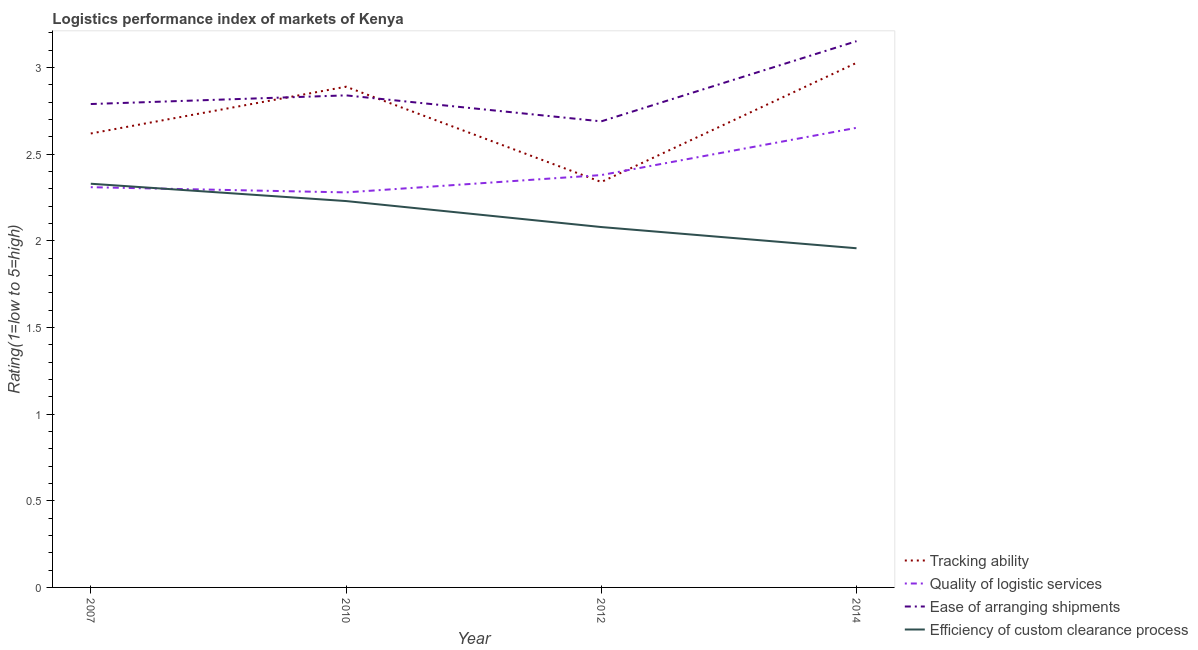How many different coloured lines are there?
Provide a short and direct response. 4. What is the lpi rating of efficiency of custom clearance process in 2014?
Your response must be concise. 1.96. Across all years, what is the maximum lpi rating of ease of arranging shipments?
Your answer should be very brief. 3.15. Across all years, what is the minimum lpi rating of quality of logistic services?
Make the answer very short. 2.28. What is the total lpi rating of ease of arranging shipments in the graph?
Provide a succinct answer. 11.47. What is the difference between the lpi rating of efficiency of custom clearance process in 2007 and that in 2010?
Offer a terse response. 0.1. What is the difference between the lpi rating of quality of logistic services in 2012 and the lpi rating of tracking ability in 2010?
Ensure brevity in your answer.  -0.51. What is the average lpi rating of quality of logistic services per year?
Offer a terse response. 2.41. In the year 2010, what is the difference between the lpi rating of quality of logistic services and lpi rating of tracking ability?
Your answer should be very brief. -0.61. What is the ratio of the lpi rating of efficiency of custom clearance process in 2012 to that in 2014?
Your answer should be compact. 1.06. Is the lpi rating of ease of arranging shipments in 2007 less than that in 2012?
Keep it short and to the point. No. Is the difference between the lpi rating of ease of arranging shipments in 2010 and 2012 greater than the difference between the lpi rating of quality of logistic services in 2010 and 2012?
Make the answer very short. Yes. What is the difference between the highest and the second highest lpi rating of efficiency of custom clearance process?
Make the answer very short. 0.1. What is the difference between the highest and the lowest lpi rating of ease of arranging shipments?
Offer a terse response. 0.46. In how many years, is the lpi rating of efficiency of custom clearance process greater than the average lpi rating of efficiency of custom clearance process taken over all years?
Keep it short and to the point. 2. Is the sum of the lpi rating of ease of arranging shipments in 2012 and 2014 greater than the maximum lpi rating of efficiency of custom clearance process across all years?
Keep it short and to the point. Yes. Is it the case that in every year, the sum of the lpi rating of ease of arranging shipments and lpi rating of quality of logistic services is greater than the sum of lpi rating of efficiency of custom clearance process and lpi rating of tracking ability?
Your answer should be very brief. Yes. Does the lpi rating of efficiency of custom clearance process monotonically increase over the years?
Provide a succinct answer. No. Is the lpi rating of efficiency of custom clearance process strictly greater than the lpi rating of ease of arranging shipments over the years?
Keep it short and to the point. No. How many years are there in the graph?
Give a very brief answer. 4. What is the difference between two consecutive major ticks on the Y-axis?
Keep it short and to the point. 0.5. Does the graph contain grids?
Your response must be concise. No. How many legend labels are there?
Offer a terse response. 4. What is the title of the graph?
Offer a very short reply. Logistics performance index of markets of Kenya. What is the label or title of the Y-axis?
Your response must be concise. Rating(1=low to 5=high). What is the Rating(1=low to 5=high) in Tracking ability in 2007?
Your answer should be compact. 2.62. What is the Rating(1=low to 5=high) in Quality of logistic services in 2007?
Make the answer very short. 2.31. What is the Rating(1=low to 5=high) of Ease of arranging shipments in 2007?
Your response must be concise. 2.79. What is the Rating(1=low to 5=high) in Efficiency of custom clearance process in 2007?
Provide a short and direct response. 2.33. What is the Rating(1=low to 5=high) of Tracking ability in 2010?
Keep it short and to the point. 2.89. What is the Rating(1=low to 5=high) in Quality of logistic services in 2010?
Make the answer very short. 2.28. What is the Rating(1=low to 5=high) of Ease of arranging shipments in 2010?
Your answer should be very brief. 2.84. What is the Rating(1=low to 5=high) in Efficiency of custom clearance process in 2010?
Your response must be concise. 2.23. What is the Rating(1=low to 5=high) of Tracking ability in 2012?
Keep it short and to the point. 2.34. What is the Rating(1=low to 5=high) in Quality of logistic services in 2012?
Provide a short and direct response. 2.38. What is the Rating(1=low to 5=high) of Ease of arranging shipments in 2012?
Offer a terse response. 2.69. What is the Rating(1=low to 5=high) in Efficiency of custom clearance process in 2012?
Ensure brevity in your answer.  2.08. What is the Rating(1=low to 5=high) of Tracking ability in 2014?
Your response must be concise. 3.03. What is the Rating(1=low to 5=high) of Quality of logistic services in 2014?
Your response must be concise. 2.65. What is the Rating(1=low to 5=high) of Ease of arranging shipments in 2014?
Give a very brief answer. 3.15. What is the Rating(1=low to 5=high) of Efficiency of custom clearance process in 2014?
Give a very brief answer. 1.96. Across all years, what is the maximum Rating(1=low to 5=high) of Tracking ability?
Offer a terse response. 3.03. Across all years, what is the maximum Rating(1=low to 5=high) in Quality of logistic services?
Make the answer very short. 2.65. Across all years, what is the maximum Rating(1=low to 5=high) in Ease of arranging shipments?
Keep it short and to the point. 3.15. Across all years, what is the maximum Rating(1=low to 5=high) in Efficiency of custom clearance process?
Your answer should be compact. 2.33. Across all years, what is the minimum Rating(1=low to 5=high) of Tracking ability?
Your answer should be compact. 2.34. Across all years, what is the minimum Rating(1=low to 5=high) of Quality of logistic services?
Provide a short and direct response. 2.28. Across all years, what is the minimum Rating(1=low to 5=high) of Ease of arranging shipments?
Your response must be concise. 2.69. Across all years, what is the minimum Rating(1=low to 5=high) of Efficiency of custom clearance process?
Make the answer very short. 1.96. What is the total Rating(1=low to 5=high) in Tracking ability in the graph?
Offer a terse response. 10.88. What is the total Rating(1=low to 5=high) in Quality of logistic services in the graph?
Keep it short and to the point. 9.62. What is the total Rating(1=low to 5=high) in Ease of arranging shipments in the graph?
Your answer should be very brief. 11.47. What is the total Rating(1=low to 5=high) in Efficiency of custom clearance process in the graph?
Ensure brevity in your answer.  8.6. What is the difference between the Rating(1=low to 5=high) of Tracking ability in 2007 and that in 2010?
Provide a short and direct response. -0.27. What is the difference between the Rating(1=low to 5=high) in Quality of logistic services in 2007 and that in 2010?
Offer a terse response. 0.03. What is the difference between the Rating(1=low to 5=high) in Efficiency of custom clearance process in 2007 and that in 2010?
Make the answer very short. 0.1. What is the difference between the Rating(1=low to 5=high) in Tracking ability in 2007 and that in 2012?
Provide a succinct answer. 0.28. What is the difference between the Rating(1=low to 5=high) of Quality of logistic services in 2007 and that in 2012?
Your response must be concise. -0.07. What is the difference between the Rating(1=low to 5=high) in Tracking ability in 2007 and that in 2014?
Provide a succinct answer. -0.41. What is the difference between the Rating(1=low to 5=high) in Quality of logistic services in 2007 and that in 2014?
Provide a succinct answer. -0.34. What is the difference between the Rating(1=low to 5=high) of Ease of arranging shipments in 2007 and that in 2014?
Keep it short and to the point. -0.36. What is the difference between the Rating(1=low to 5=high) in Efficiency of custom clearance process in 2007 and that in 2014?
Provide a short and direct response. 0.37. What is the difference between the Rating(1=low to 5=high) of Tracking ability in 2010 and that in 2012?
Provide a succinct answer. 0.55. What is the difference between the Rating(1=low to 5=high) in Quality of logistic services in 2010 and that in 2012?
Your response must be concise. -0.1. What is the difference between the Rating(1=low to 5=high) of Tracking ability in 2010 and that in 2014?
Your answer should be compact. -0.14. What is the difference between the Rating(1=low to 5=high) in Quality of logistic services in 2010 and that in 2014?
Provide a succinct answer. -0.37. What is the difference between the Rating(1=low to 5=high) of Ease of arranging shipments in 2010 and that in 2014?
Offer a very short reply. -0.31. What is the difference between the Rating(1=low to 5=high) of Efficiency of custom clearance process in 2010 and that in 2014?
Your answer should be very brief. 0.27. What is the difference between the Rating(1=low to 5=high) in Tracking ability in 2012 and that in 2014?
Keep it short and to the point. -0.69. What is the difference between the Rating(1=low to 5=high) in Quality of logistic services in 2012 and that in 2014?
Your answer should be compact. -0.27. What is the difference between the Rating(1=low to 5=high) of Ease of arranging shipments in 2012 and that in 2014?
Ensure brevity in your answer.  -0.46. What is the difference between the Rating(1=low to 5=high) of Efficiency of custom clearance process in 2012 and that in 2014?
Your response must be concise. 0.12. What is the difference between the Rating(1=low to 5=high) of Tracking ability in 2007 and the Rating(1=low to 5=high) of Quality of logistic services in 2010?
Give a very brief answer. 0.34. What is the difference between the Rating(1=low to 5=high) of Tracking ability in 2007 and the Rating(1=low to 5=high) of Ease of arranging shipments in 2010?
Make the answer very short. -0.22. What is the difference between the Rating(1=low to 5=high) of Tracking ability in 2007 and the Rating(1=low to 5=high) of Efficiency of custom clearance process in 2010?
Keep it short and to the point. 0.39. What is the difference between the Rating(1=low to 5=high) in Quality of logistic services in 2007 and the Rating(1=low to 5=high) in Ease of arranging shipments in 2010?
Give a very brief answer. -0.53. What is the difference between the Rating(1=low to 5=high) in Quality of logistic services in 2007 and the Rating(1=low to 5=high) in Efficiency of custom clearance process in 2010?
Provide a succinct answer. 0.08. What is the difference between the Rating(1=low to 5=high) in Ease of arranging shipments in 2007 and the Rating(1=low to 5=high) in Efficiency of custom clearance process in 2010?
Your answer should be very brief. 0.56. What is the difference between the Rating(1=low to 5=high) of Tracking ability in 2007 and the Rating(1=low to 5=high) of Quality of logistic services in 2012?
Provide a succinct answer. 0.24. What is the difference between the Rating(1=low to 5=high) in Tracking ability in 2007 and the Rating(1=low to 5=high) in Ease of arranging shipments in 2012?
Ensure brevity in your answer.  -0.07. What is the difference between the Rating(1=low to 5=high) of Tracking ability in 2007 and the Rating(1=low to 5=high) of Efficiency of custom clearance process in 2012?
Offer a terse response. 0.54. What is the difference between the Rating(1=low to 5=high) of Quality of logistic services in 2007 and the Rating(1=low to 5=high) of Ease of arranging shipments in 2012?
Keep it short and to the point. -0.38. What is the difference between the Rating(1=low to 5=high) of Quality of logistic services in 2007 and the Rating(1=low to 5=high) of Efficiency of custom clearance process in 2012?
Provide a short and direct response. 0.23. What is the difference between the Rating(1=low to 5=high) of Ease of arranging shipments in 2007 and the Rating(1=low to 5=high) of Efficiency of custom clearance process in 2012?
Give a very brief answer. 0.71. What is the difference between the Rating(1=low to 5=high) in Tracking ability in 2007 and the Rating(1=low to 5=high) in Quality of logistic services in 2014?
Your answer should be very brief. -0.03. What is the difference between the Rating(1=low to 5=high) of Tracking ability in 2007 and the Rating(1=low to 5=high) of Ease of arranging shipments in 2014?
Provide a short and direct response. -0.53. What is the difference between the Rating(1=low to 5=high) in Tracking ability in 2007 and the Rating(1=low to 5=high) in Efficiency of custom clearance process in 2014?
Keep it short and to the point. 0.66. What is the difference between the Rating(1=low to 5=high) of Quality of logistic services in 2007 and the Rating(1=low to 5=high) of Ease of arranging shipments in 2014?
Provide a short and direct response. -0.84. What is the difference between the Rating(1=low to 5=high) of Quality of logistic services in 2007 and the Rating(1=low to 5=high) of Efficiency of custom clearance process in 2014?
Ensure brevity in your answer.  0.35. What is the difference between the Rating(1=low to 5=high) in Ease of arranging shipments in 2007 and the Rating(1=low to 5=high) in Efficiency of custom clearance process in 2014?
Keep it short and to the point. 0.83. What is the difference between the Rating(1=low to 5=high) in Tracking ability in 2010 and the Rating(1=low to 5=high) in Quality of logistic services in 2012?
Ensure brevity in your answer.  0.51. What is the difference between the Rating(1=low to 5=high) in Tracking ability in 2010 and the Rating(1=low to 5=high) in Efficiency of custom clearance process in 2012?
Your answer should be compact. 0.81. What is the difference between the Rating(1=low to 5=high) in Quality of logistic services in 2010 and the Rating(1=low to 5=high) in Ease of arranging shipments in 2012?
Ensure brevity in your answer.  -0.41. What is the difference between the Rating(1=low to 5=high) in Quality of logistic services in 2010 and the Rating(1=low to 5=high) in Efficiency of custom clearance process in 2012?
Give a very brief answer. 0.2. What is the difference between the Rating(1=low to 5=high) of Ease of arranging shipments in 2010 and the Rating(1=low to 5=high) of Efficiency of custom clearance process in 2012?
Your response must be concise. 0.76. What is the difference between the Rating(1=low to 5=high) of Tracking ability in 2010 and the Rating(1=low to 5=high) of Quality of logistic services in 2014?
Your answer should be very brief. 0.24. What is the difference between the Rating(1=low to 5=high) in Tracking ability in 2010 and the Rating(1=low to 5=high) in Ease of arranging shipments in 2014?
Provide a succinct answer. -0.26. What is the difference between the Rating(1=low to 5=high) in Tracking ability in 2010 and the Rating(1=low to 5=high) in Efficiency of custom clearance process in 2014?
Your answer should be compact. 0.93. What is the difference between the Rating(1=low to 5=high) in Quality of logistic services in 2010 and the Rating(1=low to 5=high) in Ease of arranging shipments in 2014?
Offer a terse response. -0.87. What is the difference between the Rating(1=low to 5=high) in Quality of logistic services in 2010 and the Rating(1=low to 5=high) in Efficiency of custom clearance process in 2014?
Keep it short and to the point. 0.32. What is the difference between the Rating(1=low to 5=high) in Ease of arranging shipments in 2010 and the Rating(1=low to 5=high) in Efficiency of custom clearance process in 2014?
Offer a very short reply. 0.88. What is the difference between the Rating(1=low to 5=high) in Tracking ability in 2012 and the Rating(1=low to 5=high) in Quality of logistic services in 2014?
Provide a succinct answer. -0.31. What is the difference between the Rating(1=low to 5=high) in Tracking ability in 2012 and the Rating(1=low to 5=high) in Ease of arranging shipments in 2014?
Make the answer very short. -0.81. What is the difference between the Rating(1=low to 5=high) in Tracking ability in 2012 and the Rating(1=low to 5=high) in Efficiency of custom clearance process in 2014?
Offer a very short reply. 0.38. What is the difference between the Rating(1=low to 5=high) of Quality of logistic services in 2012 and the Rating(1=low to 5=high) of Ease of arranging shipments in 2014?
Provide a succinct answer. -0.77. What is the difference between the Rating(1=low to 5=high) of Quality of logistic services in 2012 and the Rating(1=low to 5=high) of Efficiency of custom clearance process in 2014?
Your answer should be very brief. 0.42. What is the difference between the Rating(1=low to 5=high) of Ease of arranging shipments in 2012 and the Rating(1=low to 5=high) of Efficiency of custom clearance process in 2014?
Give a very brief answer. 0.73. What is the average Rating(1=low to 5=high) of Tracking ability per year?
Give a very brief answer. 2.72. What is the average Rating(1=low to 5=high) in Quality of logistic services per year?
Provide a short and direct response. 2.41. What is the average Rating(1=low to 5=high) of Ease of arranging shipments per year?
Provide a short and direct response. 2.87. What is the average Rating(1=low to 5=high) in Efficiency of custom clearance process per year?
Provide a short and direct response. 2.15. In the year 2007, what is the difference between the Rating(1=low to 5=high) in Tracking ability and Rating(1=low to 5=high) in Quality of logistic services?
Give a very brief answer. 0.31. In the year 2007, what is the difference between the Rating(1=low to 5=high) of Tracking ability and Rating(1=low to 5=high) of Ease of arranging shipments?
Ensure brevity in your answer.  -0.17. In the year 2007, what is the difference between the Rating(1=low to 5=high) in Tracking ability and Rating(1=low to 5=high) in Efficiency of custom clearance process?
Give a very brief answer. 0.29. In the year 2007, what is the difference between the Rating(1=low to 5=high) of Quality of logistic services and Rating(1=low to 5=high) of Ease of arranging shipments?
Offer a very short reply. -0.48. In the year 2007, what is the difference between the Rating(1=low to 5=high) of Quality of logistic services and Rating(1=low to 5=high) of Efficiency of custom clearance process?
Keep it short and to the point. -0.02. In the year 2007, what is the difference between the Rating(1=low to 5=high) in Ease of arranging shipments and Rating(1=low to 5=high) in Efficiency of custom clearance process?
Provide a short and direct response. 0.46. In the year 2010, what is the difference between the Rating(1=low to 5=high) in Tracking ability and Rating(1=low to 5=high) in Quality of logistic services?
Provide a short and direct response. 0.61. In the year 2010, what is the difference between the Rating(1=low to 5=high) of Tracking ability and Rating(1=low to 5=high) of Efficiency of custom clearance process?
Your response must be concise. 0.66. In the year 2010, what is the difference between the Rating(1=low to 5=high) of Quality of logistic services and Rating(1=low to 5=high) of Ease of arranging shipments?
Provide a short and direct response. -0.56. In the year 2010, what is the difference between the Rating(1=low to 5=high) of Quality of logistic services and Rating(1=low to 5=high) of Efficiency of custom clearance process?
Provide a succinct answer. 0.05. In the year 2010, what is the difference between the Rating(1=low to 5=high) in Ease of arranging shipments and Rating(1=low to 5=high) in Efficiency of custom clearance process?
Your answer should be compact. 0.61. In the year 2012, what is the difference between the Rating(1=low to 5=high) in Tracking ability and Rating(1=low to 5=high) in Quality of logistic services?
Make the answer very short. -0.04. In the year 2012, what is the difference between the Rating(1=low to 5=high) of Tracking ability and Rating(1=low to 5=high) of Ease of arranging shipments?
Your answer should be very brief. -0.35. In the year 2012, what is the difference between the Rating(1=low to 5=high) in Tracking ability and Rating(1=low to 5=high) in Efficiency of custom clearance process?
Provide a succinct answer. 0.26. In the year 2012, what is the difference between the Rating(1=low to 5=high) of Quality of logistic services and Rating(1=low to 5=high) of Ease of arranging shipments?
Ensure brevity in your answer.  -0.31. In the year 2012, what is the difference between the Rating(1=low to 5=high) of Ease of arranging shipments and Rating(1=low to 5=high) of Efficiency of custom clearance process?
Provide a succinct answer. 0.61. In the year 2014, what is the difference between the Rating(1=low to 5=high) in Tracking ability and Rating(1=low to 5=high) in Quality of logistic services?
Your response must be concise. 0.38. In the year 2014, what is the difference between the Rating(1=low to 5=high) in Tracking ability and Rating(1=low to 5=high) in Ease of arranging shipments?
Offer a very short reply. -0.12. In the year 2014, what is the difference between the Rating(1=low to 5=high) in Tracking ability and Rating(1=low to 5=high) in Efficiency of custom clearance process?
Offer a very short reply. 1.07. In the year 2014, what is the difference between the Rating(1=low to 5=high) of Quality of logistic services and Rating(1=low to 5=high) of Efficiency of custom clearance process?
Give a very brief answer. 0.7. In the year 2014, what is the difference between the Rating(1=low to 5=high) in Ease of arranging shipments and Rating(1=low to 5=high) in Efficiency of custom clearance process?
Your response must be concise. 1.2. What is the ratio of the Rating(1=low to 5=high) in Tracking ability in 2007 to that in 2010?
Keep it short and to the point. 0.91. What is the ratio of the Rating(1=low to 5=high) of Quality of logistic services in 2007 to that in 2010?
Your answer should be compact. 1.01. What is the ratio of the Rating(1=low to 5=high) in Ease of arranging shipments in 2007 to that in 2010?
Ensure brevity in your answer.  0.98. What is the ratio of the Rating(1=low to 5=high) of Efficiency of custom clearance process in 2007 to that in 2010?
Give a very brief answer. 1.04. What is the ratio of the Rating(1=low to 5=high) in Tracking ability in 2007 to that in 2012?
Offer a terse response. 1.12. What is the ratio of the Rating(1=low to 5=high) of Quality of logistic services in 2007 to that in 2012?
Ensure brevity in your answer.  0.97. What is the ratio of the Rating(1=low to 5=high) in Ease of arranging shipments in 2007 to that in 2012?
Your response must be concise. 1.04. What is the ratio of the Rating(1=low to 5=high) of Efficiency of custom clearance process in 2007 to that in 2012?
Your answer should be very brief. 1.12. What is the ratio of the Rating(1=low to 5=high) in Tracking ability in 2007 to that in 2014?
Your response must be concise. 0.87. What is the ratio of the Rating(1=low to 5=high) of Quality of logistic services in 2007 to that in 2014?
Offer a very short reply. 0.87. What is the ratio of the Rating(1=low to 5=high) of Ease of arranging shipments in 2007 to that in 2014?
Keep it short and to the point. 0.88. What is the ratio of the Rating(1=low to 5=high) of Efficiency of custom clearance process in 2007 to that in 2014?
Keep it short and to the point. 1.19. What is the ratio of the Rating(1=low to 5=high) in Tracking ability in 2010 to that in 2012?
Make the answer very short. 1.24. What is the ratio of the Rating(1=low to 5=high) in Quality of logistic services in 2010 to that in 2012?
Offer a terse response. 0.96. What is the ratio of the Rating(1=low to 5=high) of Ease of arranging shipments in 2010 to that in 2012?
Offer a very short reply. 1.06. What is the ratio of the Rating(1=low to 5=high) of Efficiency of custom clearance process in 2010 to that in 2012?
Provide a succinct answer. 1.07. What is the ratio of the Rating(1=low to 5=high) of Tracking ability in 2010 to that in 2014?
Make the answer very short. 0.95. What is the ratio of the Rating(1=low to 5=high) in Quality of logistic services in 2010 to that in 2014?
Keep it short and to the point. 0.86. What is the ratio of the Rating(1=low to 5=high) of Ease of arranging shipments in 2010 to that in 2014?
Make the answer very short. 0.9. What is the ratio of the Rating(1=low to 5=high) of Efficiency of custom clearance process in 2010 to that in 2014?
Provide a short and direct response. 1.14. What is the ratio of the Rating(1=low to 5=high) of Tracking ability in 2012 to that in 2014?
Ensure brevity in your answer.  0.77. What is the ratio of the Rating(1=low to 5=high) in Quality of logistic services in 2012 to that in 2014?
Provide a succinct answer. 0.9. What is the ratio of the Rating(1=low to 5=high) of Ease of arranging shipments in 2012 to that in 2014?
Keep it short and to the point. 0.85. What is the ratio of the Rating(1=low to 5=high) of Efficiency of custom clearance process in 2012 to that in 2014?
Your response must be concise. 1.06. What is the difference between the highest and the second highest Rating(1=low to 5=high) in Tracking ability?
Give a very brief answer. 0.14. What is the difference between the highest and the second highest Rating(1=low to 5=high) of Quality of logistic services?
Your answer should be very brief. 0.27. What is the difference between the highest and the second highest Rating(1=low to 5=high) in Ease of arranging shipments?
Provide a short and direct response. 0.31. What is the difference between the highest and the lowest Rating(1=low to 5=high) in Tracking ability?
Provide a short and direct response. 0.69. What is the difference between the highest and the lowest Rating(1=low to 5=high) in Quality of logistic services?
Offer a very short reply. 0.37. What is the difference between the highest and the lowest Rating(1=low to 5=high) in Ease of arranging shipments?
Provide a short and direct response. 0.46. What is the difference between the highest and the lowest Rating(1=low to 5=high) in Efficiency of custom clearance process?
Your response must be concise. 0.37. 